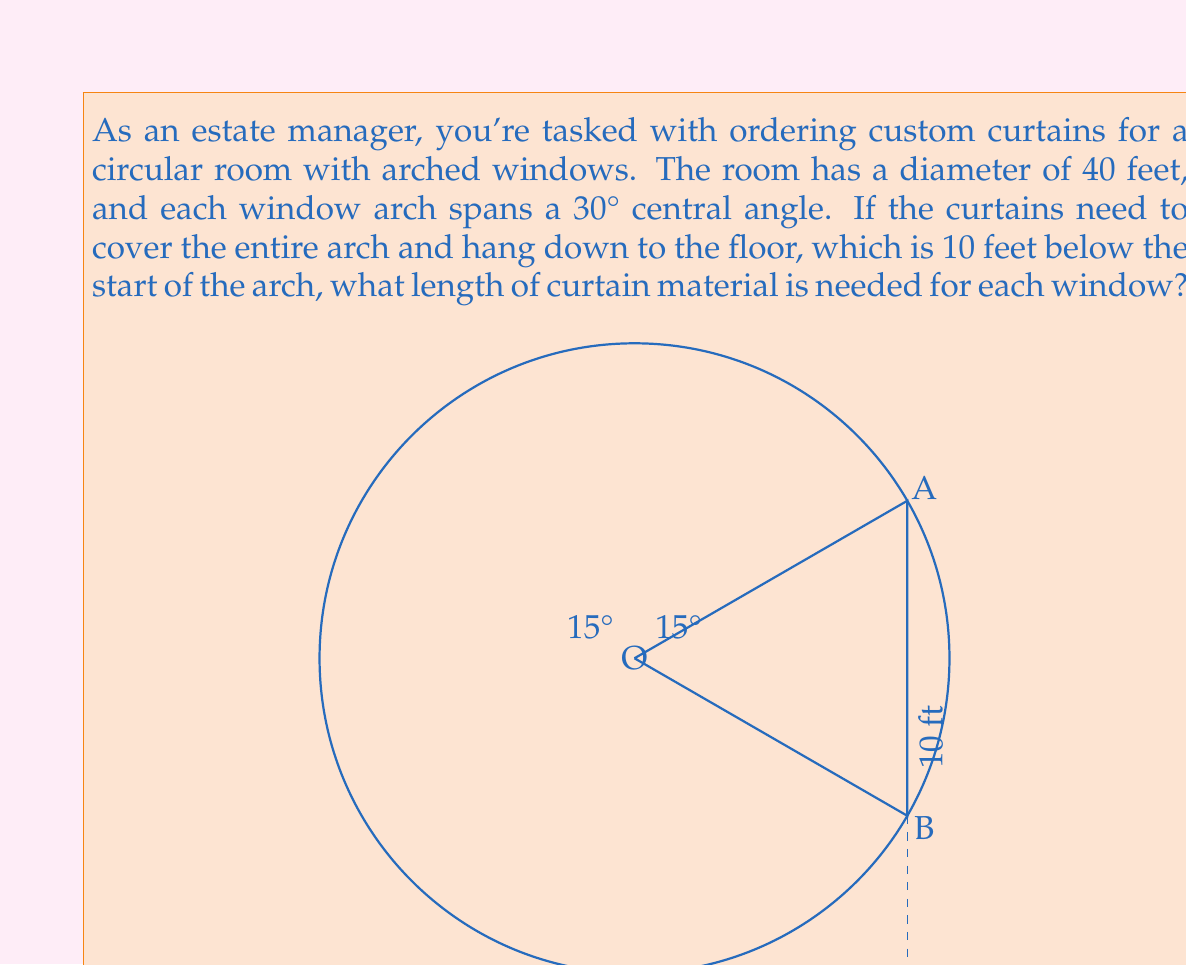Could you help me with this problem? Let's approach this problem step by step:

1) First, we need to find the radius of the circular room:
   Diameter = 40 feet, so radius $r = 20$ feet

2) The length of the curtain will consist of two parts:
   a) The length of the arc (curved part)
   b) The straight part from the bottom of the arc to the floor

3) To find the length of the arc, we use the formula:
   $s = r\theta$, where $s$ is arc length, $r$ is radius, and $\theta$ is the angle in radians

4) Convert 30° to radians:
   $\theta = 30° \times \frac{\pi}{180°} = \frac{\pi}{6}$ radians

5) Calculate the arc length:
   $s = 20 \times \frac{\pi}{6} = \frac{10\pi}{3}$ feet

6) For the straight part, we need to find the height of the arc first:
   Height of arc = $r - r\cos(\frac{\theta}{2}) = 20 - 20\cos(15°) \approx 0.7612$ feet

7) Length of straight part = 10 feet - 0.7612 feet = 9.2388 feet

8) Total length of curtain = Arc length + Straight part
   $= \frac{10\pi}{3} + 9.2388 \approx 19.7392$ feet
Answer: The length of curtain material needed for each window is approximately 19.74 feet. 